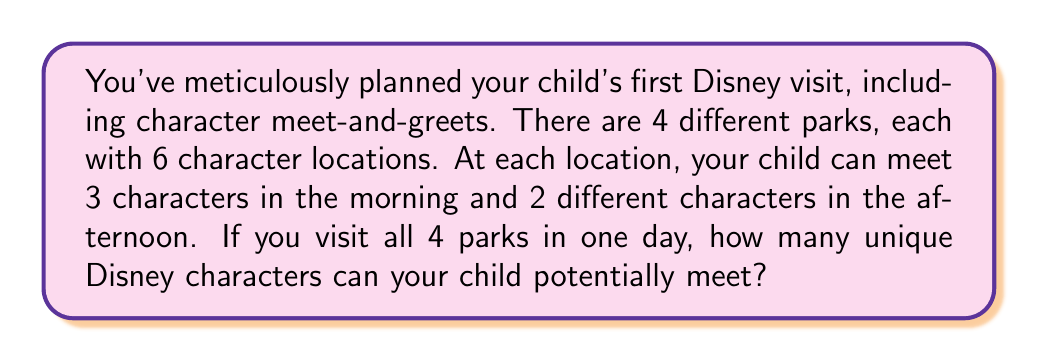Help me with this question. Let's break this down step-by-step:

1. Number of parks: 4
2. Character locations per park: 6
3. Characters per location in the morning: 3
4. Characters per location in the afternoon: 2

To calculate the total number of characters:

1. Characters per park:
   Morning: $6 \times 3 = 18$
   Afternoon: $6 \times 2 = 12$
   Total per park: $18 + 12 = 30$

2. Total characters across all parks:
   $30 \times 4 = 120$

Therefore, the total number of unique Disney characters your child can potentially meet in one day, visiting all 4 parks, is:

$$4 \text{ parks} \times (6 \text{ locations} \times (3 \text{ morning} + 2 \text{ afternoon})) = 120 \text{ characters}$$
Answer: 120 characters 